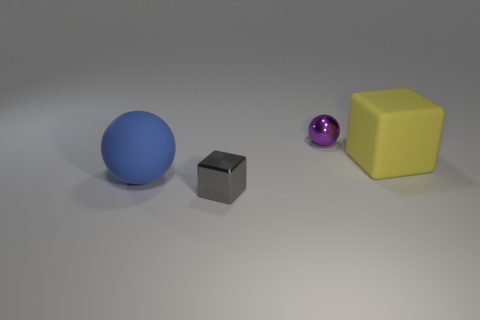What number of balls are large blue rubber things or red rubber things?
Make the answer very short. 1. Is the number of blue rubber things behind the rubber cube less than the number of large yellow matte objects?
Make the answer very short. Yes. What is the color of the thing that is both in front of the yellow rubber thing and right of the big blue sphere?
Provide a short and direct response. Gray. What number of other objects are the same shape as the yellow object?
Keep it short and to the point. 1. Is the number of purple spheres in front of the rubber block less than the number of small metal spheres that are behind the tiny purple metal sphere?
Provide a succinct answer. No. Is the material of the small ball the same as the tiny thing in front of the yellow object?
Ensure brevity in your answer.  Yes. Are there any other things that have the same material as the yellow object?
Offer a very short reply. Yes. Is the number of large yellow blocks greater than the number of large gray metal objects?
Make the answer very short. Yes. What is the shape of the metallic thing that is behind the thing that is on the left side of the small object in front of the large blue object?
Provide a succinct answer. Sphere. Is the block that is to the right of the small cube made of the same material as the purple thing that is left of the yellow matte block?
Keep it short and to the point. No. 